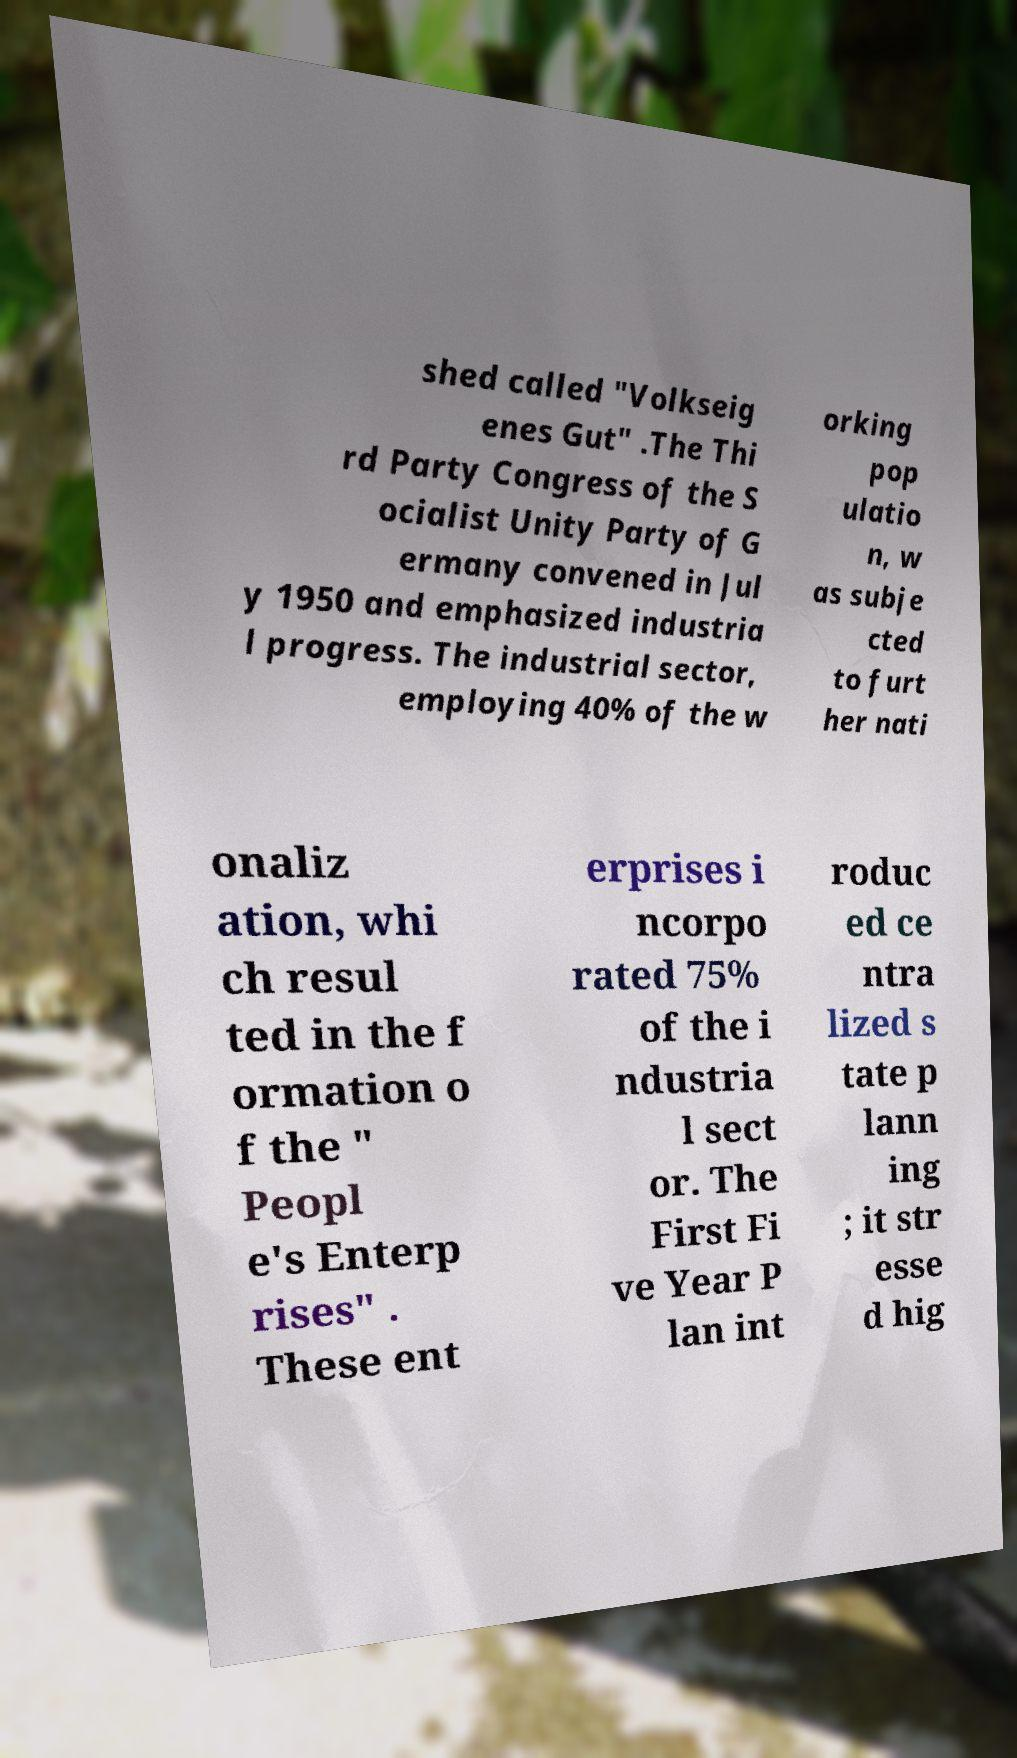I need the written content from this picture converted into text. Can you do that? shed called "Volkseig enes Gut" .The Thi rd Party Congress of the S ocialist Unity Party of G ermany convened in Jul y 1950 and emphasized industria l progress. The industrial sector, employing 40% of the w orking pop ulatio n, w as subje cted to furt her nati onaliz ation, whi ch resul ted in the f ormation o f the " Peopl e's Enterp rises" . These ent erprises i ncorpo rated 75% of the i ndustria l sect or. The First Fi ve Year P lan int roduc ed ce ntra lized s tate p lann ing ; it str esse d hig 